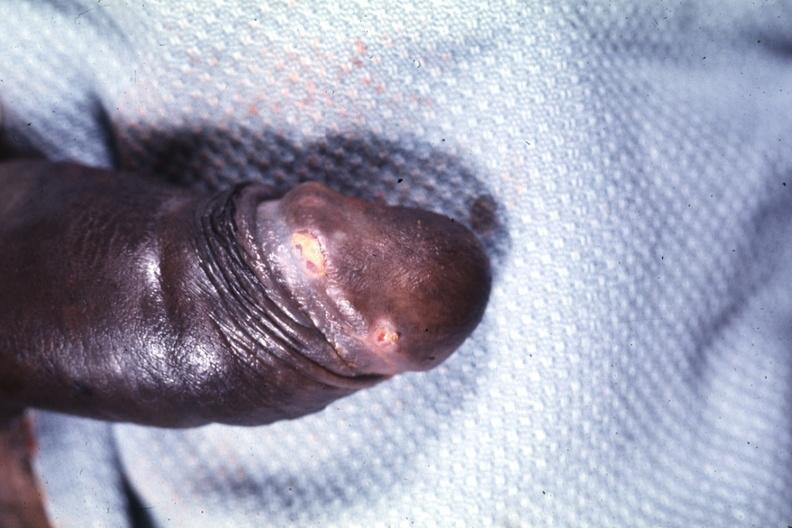what does this image show?
Answer the question using a single word or phrase. Glans ulcers probable herpes 